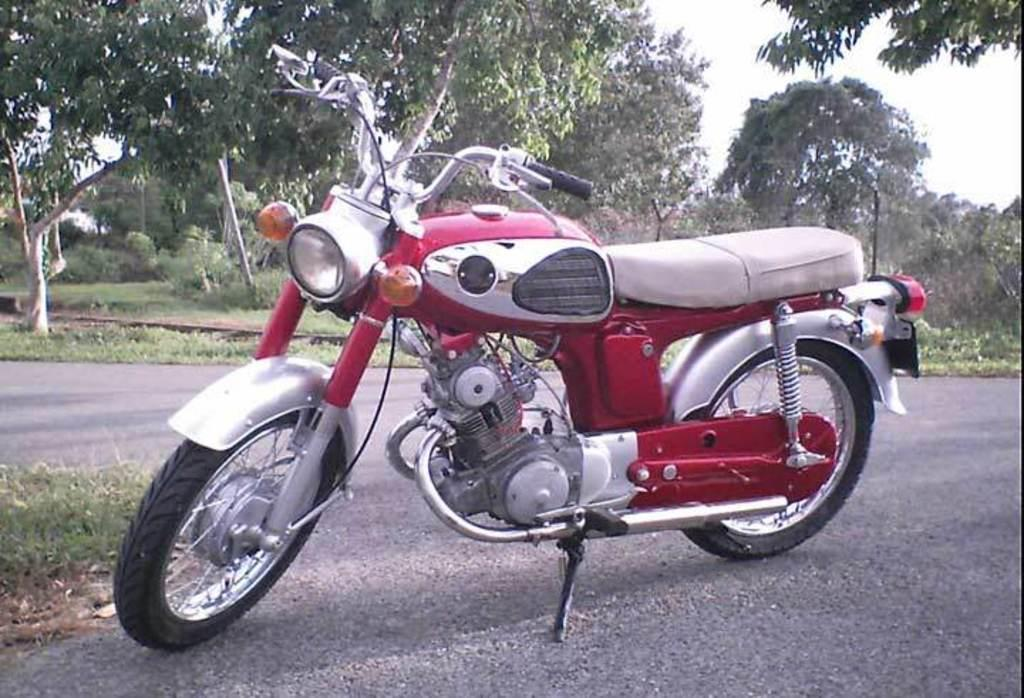What is the main subject of the image? The main subject of the image is a motorbike. Where is the motorbike located? The motorbike is on the road. What can be seen in the background of the image? There are many trees and the sky visible in the background of the image. What color is the orange on the tail of the motorbike in the image? There is no orange or tail present on the motorbike in the image. 